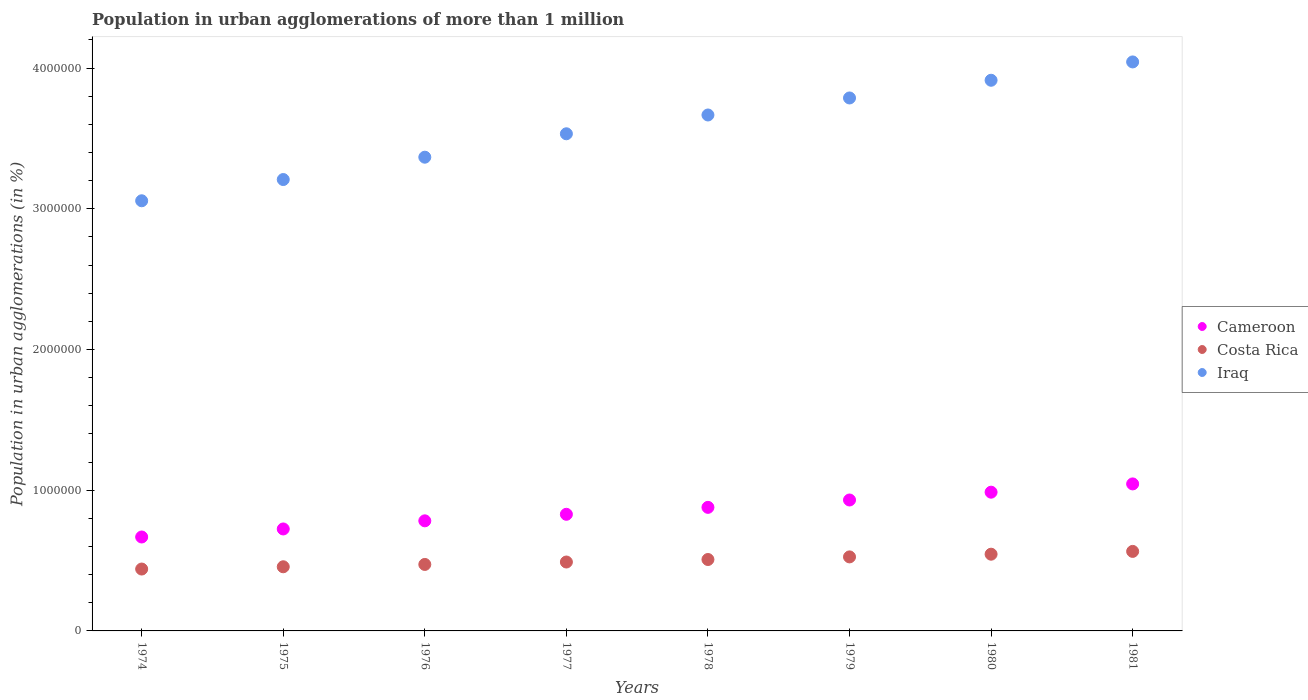How many different coloured dotlines are there?
Make the answer very short. 3. Is the number of dotlines equal to the number of legend labels?
Provide a short and direct response. Yes. What is the population in urban agglomerations in Iraq in 1975?
Give a very brief answer. 3.21e+06. Across all years, what is the maximum population in urban agglomerations in Iraq?
Your answer should be compact. 4.04e+06. Across all years, what is the minimum population in urban agglomerations in Cameroon?
Keep it short and to the point. 6.67e+05. In which year was the population in urban agglomerations in Cameroon maximum?
Give a very brief answer. 1981. In which year was the population in urban agglomerations in Costa Rica minimum?
Ensure brevity in your answer.  1974. What is the total population in urban agglomerations in Costa Rica in the graph?
Your response must be concise. 4.00e+06. What is the difference between the population in urban agglomerations in Iraq in 1979 and that in 1980?
Offer a terse response. -1.26e+05. What is the difference between the population in urban agglomerations in Cameroon in 1981 and the population in urban agglomerations in Costa Rica in 1977?
Your answer should be compact. 5.55e+05. What is the average population in urban agglomerations in Iraq per year?
Your answer should be compact. 3.57e+06. In the year 1978, what is the difference between the population in urban agglomerations in Costa Rica and population in urban agglomerations in Iraq?
Give a very brief answer. -3.16e+06. What is the ratio of the population in urban agglomerations in Iraq in 1974 to that in 1976?
Offer a very short reply. 0.91. Is the population in urban agglomerations in Iraq in 1978 less than that in 1981?
Your answer should be very brief. Yes. Is the difference between the population in urban agglomerations in Costa Rica in 1974 and 1978 greater than the difference between the population in urban agglomerations in Iraq in 1974 and 1978?
Give a very brief answer. Yes. What is the difference between the highest and the second highest population in urban agglomerations in Cameroon?
Make the answer very short. 5.87e+04. What is the difference between the highest and the lowest population in urban agglomerations in Costa Rica?
Keep it short and to the point. 1.25e+05. Is the population in urban agglomerations in Iraq strictly greater than the population in urban agglomerations in Costa Rica over the years?
Your response must be concise. Yes. Is the population in urban agglomerations in Iraq strictly less than the population in urban agglomerations in Costa Rica over the years?
Keep it short and to the point. No. How many dotlines are there?
Your answer should be compact. 3. How many years are there in the graph?
Offer a terse response. 8. What is the difference between two consecutive major ticks on the Y-axis?
Provide a short and direct response. 1.00e+06. Are the values on the major ticks of Y-axis written in scientific E-notation?
Provide a short and direct response. No. Does the graph contain grids?
Your response must be concise. No. How many legend labels are there?
Give a very brief answer. 3. What is the title of the graph?
Your answer should be very brief. Population in urban agglomerations of more than 1 million. What is the label or title of the X-axis?
Your response must be concise. Years. What is the label or title of the Y-axis?
Keep it short and to the point. Population in urban agglomerations (in %). What is the Population in urban agglomerations (in %) of Cameroon in 1974?
Offer a terse response. 6.67e+05. What is the Population in urban agglomerations (in %) of Costa Rica in 1974?
Keep it short and to the point. 4.40e+05. What is the Population in urban agglomerations (in %) of Iraq in 1974?
Your answer should be very brief. 3.06e+06. What is the Population in urban agglomerations (in %) of Cameroon in 1975?
Your response must be concise. 7.25e+05. What is the Population in urban agglomerations (in %) of Costa Rica in 1975?
Your response must be concise. 4.56e+05. What is the Population in urban agglomerations (in %) of Iraq in 1975?
Give a very brief answer. 3.21e+06. What is the Population in urban agglomerations (in %) of Cameroon in 1976?
Give a very brief answer. 7.82e+05. What is the Population in urban agglomerations (in %) of Costa Rica in 1976?
Your answer should be very brief. 4.72e+05. What is the Population in urban agglomerations (in %) in Iraq in 1976?
Provide a short and direct response. 3.37e+06. What is the Population in urban agglomerations (in %) in Cameroon in 1977?
Give a very brief answer. 8.29e+05. What is the Population in urban agglomerations (in %) in Costa Rica in 1977?
Ensure brevity in your answer.  4.90e+05. What is the Population in urban agglomerations (in %) in Iraq in 1977?
Provide a succinct answer. 3.53e+06. What is the Population in urban agglomerations (in %) of Cameroon in 1978?
Provide a short and direct response. 8.78e+05. What is the Population in urban agglomerations (in %) of Costa Rica in 1978?
Give a very brief answer. 5.07e+05. What is the Population in urban agglomerations (in %) in Iraq in 1978?
Your answer should be compact. 3.67e+06. What is the Population in urban agglomerations (in %) of Cameroon in 1979?
Your answer should be very brief. 9.30e+05. What is the Population in urban agglomerations (in %) of Costa Rica in 1979?
Offer a very short reply. 5.26e+05. What is the Population in urban agglomerations (in %) of Iraq in 1979?
Your answer should be compact. 3.79e+06. What is the Population in urban agglomerations (in %) in Cameroon in 1980?
Offer a very short reply. 9.86e+05. What is the Population in urban agglomerations (in %) in Costa Rica in 1980?
Ensure brevity in your answer.  5.45e+05. What is the Population in urban agglomerations (in %) of Iraq in 1980?
Your response must be concise. 3.91e+06. What is the Population in urban agglomerations (in %) of Cameroon in 1981?
Ensure brevity in your answer.  1.04e+06. What is the Population in urban agglomerations (in %) in Costa Rica in 1981?
Provide a short and direct response. 5.65e+05. What is the Population in urban agglomerations (in %) in Iraq in 1981?
Provide a short and direct response. 4.04e+06. Across all years, what is the maximum Population in urban agglomerations (in %) in Cameroon?
Offer a very short reply. 1.04e+06. Across all years, what is the maximum Population in urban agglomerations (in %) in Costa Rica?
Ensure brevity in your answer.  5.65e+05. Across all years, what is the maximum Population in urban agglomerations (in %) in Iraq?
Offer a very short reply. 4.04e+06. Across all years, what is the minimum Population in urban agglomerations (in %) in Cameroon?
Make the answer very short. 6.67e+05. Across all years, what is the minimum Population in urban agglomerations (in %) of Costa Rica?
Your answer should be compact. 4.40e+05. Across all years, what is the minimum Population in urban agglomerations (in %) in Iraq?
Offer a very short reply. 3.06e+06. What is the total Population in urban agglomerations (in %) of Cameroon in the graph?
Your answer should be compact. 6.84e+06. What is the total Population in urban agglomerations (in %) in Costa Rica in the graph?
Offer a very short reply. 4.00e+06. What is the total Population in urban agglomerations (in %) of Iraq in the graph?
Make the answer very short. 2.86e+07. What is the difference between the Population in urban agglomerations (in %) in Cameroon in 1974 and that in 1975?
Provide a succinct answer. -5.71e+04. What is the difference between the Population in urban agglomerations (in %) of Costa Rica in 1974 and that in 1975?
Provide a short and direct response. -1.61e+04. What is the difference between the Population in urban agglomerations (in %) in Iraq in 1974 and that in 1975?
Your response must be concise. -1.51e+05. What is the difference between the Population in urban agglomerations (in %) of Cameroon in 1974 and that in 1976?
Provide a succinct answer. -1.15e+05. What is the difference between the Population in urban agglomerations (in %) of Costa Rica in 1974 and that in 1976?
Make the answer very short. -3.27e+04. What is the difference between the Population in urban agglomerations (in %) of Iraq in 1974 and that in 1976?
Provide a succinct answer. -3.10e+05. What is the difference between the Population in urban agglomerations (in %) in Cameroon in 1974 and that in 1977?
Provide a short and direct response. -1.61e+05. What is the difference between the Population in urban agglomerations (in %) of Costa Rica in 1974 and that in 1977?
Your answer should be very brief. -4.99e+04. What is the difference between the Population in urban agglomerations (in %) of Iraq in 1974 and that in 1977?
Offer a very short reply. -4.76e+05. What is the difference between the Population in urban agglomerations (in %) in Cameroon in 1974 and that in 1978?
Keep it short and to the point. -2.11e+05. What is the difference between the Population in urban agglomerations (in %) in Costa Rica in 1974 and that in 1978?
Offer a terse response. -6.77e+04. What is the difference between the Population in urban agglomerations (in %) in Iraq in 1974 and that in 1978?
Provide a short and direct response. -6.10e+05. What is the difference between the Population in urban agglomerations (in %) of Cameroon in 1974 and that in 1979?
Make the answer very short. -2.63e+05. What is the difference between the Population in urban agglomerations (in %) of Costa Rica in 1974 and that in 1979?
Offer a terse response. -8.63e+04. What is the difference between the Population in urban agglomerations (in %) in Iraq in 1974 and that in 1979?
Provide a short and direct response. -7.31e+05. What is the difference between the Population in urban agglomerations (in %) of Cameroon in 1974 and that in 1980?
Provide a short and direct response. -3.18e+05. What is the difference between the Population in urban agglomerations (in %) in Costa Rica in 1974 and that in 1980?
Ensure brevity in your answer.  -1.05e+05. What is the difference between the Population in urban agglomerations (in %) of Iraq in 1974 and that in 1980?
Your answer should be compact. -8.56e+05. What is the difference between the Population in urban agglomerations (in %) of Cameroon in 1974 and that in 1981?
Provide a succinct answer. -3.77e+05. What is the difference between the Population in urban agglomerations (in %) in Costa Rica in 1974 and that in 1981?
Your response must be concise. -1.25e+05. What is the difference between the Population in urban agglomerations (in %) of Iraq in 1974 and that in 1981?
Your response must be concise. -9.87e+05. What is the difference between the Population in urban agglomerations (in %) of Cameroon in 1975 and that in 1976?
Offer a very short reply. -5.78e+04. What is the difference between the Population in urban agglomerations (in %) in Costa Rica in 1975 and that in 1976?
Offer a terse response. -1.66e+04. What is the difference between the Population in urban agglomerations (in %) of Iraq in 1975 and that in 1976?
Offer a terse response. -1.59e+05. What is the difference between the Population in urban agglomerations (in %) of Cameroon in 1975 and that in 1977?
Provide a succinct answer. -1.04e+05. What is the difference between the Population in urban agglomerations (in %) in Costa Rica in 1975 and that in 1977?
Offer a very short reply. -3.38e+04. What is the difference between the Population in urban agglomerations (in %) in Iraq in 1975 and that in 1977?
Give a very brief answer. -3.25e+05. What is the difference between the Population in urban agglomerations (in %) in Cameroon in 1975 and that in 1978?
Offer a very short reply. -1.54e+05. What is the difference between the Population in urban agglomerations (in %) in Costa Rica in 1975 and that in 1978?
Give a very brief answer. -5.17e+04. What is the difference between the Population in urban agglomerations (in %) of Iraq in 1975 and that in 1978?
Give a very brief answer. -4.59e+05. What is the difference between the Population in urban agglomerations (in %) in Cameroon in 1975 and that in 1979?
Offer a very short reply. -2.06e+05. What is the difference between the Population in urban agglomerations (in %) of Costa Rica in 1975 and that in 1979?
Give a very brief answer. -7.02e+04. What is the difference between the Population in urban agglomerations (in %) of Iraq in 1975 and that in 1979?
Keep it short and to the point. -5.80e+05. What is the difference between the Population in urban agglomerations (in %) in Cameroon in 1975 and that in 1980?
Give a very brief answer. -2.61e+05. What is the difference between the Population in urban agglomerations (in %) in Costa Rica in 1975 and that in 1980?
Offer a terse response. -8.94e+04. What is the difference between the Population in urban agglomerations (in %) in Iraq in 1975 and that in 1980?
Your answer should be very brief. -7.05e+05. What is the difference between the Population in urban agglomerations (in %) in Cameroon in 1975 and that in 1981?
Ensure brevity in your answer.  -3.20e+05. What is the difference between the Population in urban agglomerations (in %) in Costa Rica in 1975 and that in 1981?
Your response must be concise. -1.09e+05. What is the difference between the Population in urban agglomerations (in %) of Iraq in 1975 and that in 1981?
Make the answer very short. -8.36e+05. What is the difference between the Population in urban agglomerations (in %) of Cameroon in 1976 and that in 1977?
Your answer should be very brief. -4.64e+04. What is the difference between the Population in urban agglomerations (in %) of Costa Rica in 1976 and that in 1977?
Make the answer very short. -1.72e+04. What is the difference between the Population in urban agglomerations (in %) in Iraq in 1976 and that in 1977?
Keep it short and to the point. -1.66e+05. What is the difference between the Population in urban agglomerations (in %) in Cameroon in 1976 and that in 1978?
Keep it short and to the point. -9.57e+04. What is the difference between the Population in urban agglomerations (in %) of Costa Rica in 1976 and that in 1978?
Your answer should be compact. -3.51e+04. What is the difference between the Population in urban agglomerations (in %) in Iraq in 1976 and that in 1978?
Offer a terse response. -3.00e+05. What is the difference between the Population in urban agglomerations (in %) of Cameroon in 1976 and that in 1979?
Your answer should be very brief. -1.48e+05. What is the difference between the Population in urban agglomerations (in %) of Costa Rica in 1976 and that in 1979?
Give a very brief answer. -5.36e+04. What is the difference between the Population in urban agglomerations (in %) in Iraq in 1976 and that in 1979?
Ensure brevity in your answer.  -4.21e+05. What is the difference between the Population in urban agglomerations (in %) of Cameroon in 1976 and that in 1980?
Your answer should be very brief. -2.04e+05. What is the difference between the Population in urban agglomerations (in %) of Costa Rica in 1976 and that in 1980?
Your answer should be very brief. -7.28e+04. What is the difference between the Population in urban agglomerations (in %) of Iraq in 1976 and that in 1980?
Your answer should be very brief. -5.47e+05. What is the difference between the Population in urban agglomerations (in %) in Cameroon in 1976 and that in 1981?
Provide a short and direct response. -2.62e+05. What is the difference between the Population in urban agglomerations (in %) of Costa Rica in 1976 and that in 1981?
Give a very brief answer. -9.26e+04. What is the difference between the Population in urban agglomerations (in %) in Iraq in 1976 and that in 1981?
Offer a very short reply. -6.77e+05. What is the difference between the Population in urban agglomerations (in %) in Cameroon in 1977 and that in 1978?
Your answer should be very brief. -4.93e+04. What is the difference between the Population in urban agglomerations (in %) in Costa Rica in 1977 and that in 1978?
Provide a short and direct response. -1.79e+04. What is the difference between the Population in urban agglomerations (in %) of Iraq in 1977 and that in 1978?
Provide a succinct answer. -1.34e+05. What is the difference between the Population in urban agglomerations (in %) of Cameroon in 1977 and that in 1979?
Your answer should be very brief. -1.02e+05. What is the difference between the Population in urban agglomerations (in %) of Costa Rica in 1977 and that in 1979?
Provide a short and direct response. -3.64e+04. What is the difference between the Population in urban agglomerations (in %) of Iraq in 1977 and that in 1979?
Offer a terse response. -2.55e+05. What is the difference between the Population in urban agglomerations (in %) of Cameroon in 1977 and that in 1980?
Offer a terse response. -1.57e+05. What is the difference between the Population in urban agglomerations (in %) of Costa Rica in 1977 and that in 1980?
Offer a terse response. -5.55e+04. What is the difference between the Population in urban agglomerations (in %) of Iraq in 1977 and that in 1980?
Ensure brevity in your answer.  -3.80e+05. What is the difference between the Population in urban agglomerations (in %) of Cameroon in 1977 and that in 1981?
Provide a short and direct response. -2.16e+05. What is the difference between the Population in urban agglomerations (in %) of Costa Rica in 1977 and that in 1981?
Give a very brief answer. -7.54e+04. What is the difference between the Population in urban agglomerations (in %) in Iraq in 1977 and that in 1981?
Provide a short and direct response. -5.11e+05. What is the difference between the Population in urban agglomerations (in %) of Cameroon in 1978 and that in 1979?
Give a very brief answer. -5.23e+04. What is the difference between the Population in urban agglomerations (in %) of Costa Rica in 1978 and that in 1979?
Your answer should be very brief. -1.85e+04. What is the difference between the Population in urban agglomerations (in %) in Iraq in 1978 and that in 1979?
Your response must be concise. -1.21e+05. What is the difference between the Population in urban agglomerations (in %) in Cameroon in 1978 and that in 1980?
Give a very brief answer. -1.08e+05. What is the difference between the Population in urban agglomerations (in %) of Costa Rica in 1978 and that in 1980?
Offer a very short reply. -3.77e+04. What is the difference between the Population in urban agglomerations (in %) of Iraq in 1978 and that in 1980?
Keep it short and to the point. -2.47e+05. What is the difference between the Population in urban agglomerations (in %) of Cameroon in 1978 and that in 1981?
Your response must be concise. -1.67e+05. What is the difference between the Population in urban agglomerations (in %) of Costa Rica in 1978 and that in 1981?
Ensure brevity in your answer.  -5.76e+04. What is the difference between the Population in urban agglomerations (in %) in Iraq in 1978 and that in 1981?
Provide a short and direct response. -3.77e+05. What is the difference between the Population in urban agglomerations (in %) of Cameroon in 1979 and that in 1980?
Offer a terse response. -5.55e+04. What is the difference between the Population in urban agglomerations (in %) in Costa Rica in 1979 and that in 1980?
Offer a terse response. -1.92e+04. What is the difference between the Population in urban agglomerations (in %) of Iraq in 1979 and that in 1980?
Give a very brief answer. -1.26e+05. What is the difference between the Population in urban agglomerations (in %) in Cameroon in 1979 and that in 1981?
Offer a very short reply. -1.14e+05. What is the difference between the Population in urban agglomerations (in %) of Costa Rica in 1979 and that in 1981?
Provide a succinct answer. -3.90e+04. What is the difference between the Population in urban agglomerations (in %) in Iraq in 1979 and that in 1981?
Your answer should be very brief. -2.56e+05. What is the difference between the Population in urban agglomerations (in %) in Cameroon in 1980 and that in 1981?
Make the answer very short. -5.87e+04. What is the difference between the Population in urban agglomerations (in %) of Costa Rica in 1980 and that in 1981?
Provide a succinct answer. -1.99e+04. What is the difference between the Population in urban agglomerations (in %) in Iraq in 1980 and that in 1981?
Ensure brevity in your answer.  -1.30e+05. What is the difference between the Population in urban agglomerations (in %) of Cameroon in 1974 and the Population in urban agglomerations (in %) of Costa Rica in 1975?
Offer a very short reply. 2.12e+05. What is the difference between the Population in urban agglomerations (in %) in Cameroon in 1974 and the Population in urban agglomerations (in %) in Iraq in 1975?
Your answer should be very brief. -2.54e+06. What is the difference between the Population in urban agglomerations (in %) of Costa Rica in 1974 and the Population in urban agglomerations (in %) of Iraq in 1975?
Keep it short and to the point. -2.77e+06. What is the difference between the Population in urban agglomerations (in %) in Cameroon in 1974 and the Population in urban agglomerations (in %) in Costa Rica in 1976?
Ensure brevity in your answer.  1.95e+05. What is the difference between the Population in urban agglomerations (in %) of Cameroon in 1974 and the Population in urban agglomerations (in %) of Iraq in 1976?
Provide a short and direct response. -2.70e+06. What is the difference between the Population in urban agglomerations (in %) in Costa Rica in 1974 and the Population in urban agglomerations (in %) in Iraq in 1976?
Your answer should be very brief. -2.93e+06. What is the difference between the Population in urban agglomerations (in %) in Cameroon in 1974 and the Population in urban agglomerations (in %) in Costa Rica in 1977?
Make the answer very short. 1.78e+05. What is the difference between the Population in urban agglomerations (in %) of Cameroon in 1974 and the Population in urban agglomerations (in %) of Iraq in 1977?
Give a very brief answer. -2.87e+06. What is the difference between the Population in urban agglomerations (in %) of Costa Rica in 1974 and the Population in urban agglomerations (in %) of Iraq in 1977?
Your response must be concise. -3.09e+06. What is the difference between the Population in urban agglomerations (in %) of Cameroon in 1974 and the Population in urban agglomerations (in %) of Costa Rica in 1978?
Make the answer very short. 1.60e+05. What is the difference between the Population in urban agglomerations (in %) of Cameroon in 1974 and the Population in urban agglomerations (in %) of Iraq in 1978?
Provide a succinct answer. -3.00e+06. What is the difference between the Population in urban agglomerations (in %) of Costa Rica in 1974 and the Population in urban agglomerations (in %) of Iraq in 1978?
Provide a succinct answer. -3.23e+06. What is the difference between the Population in urban agglomerations (in %) in Cameroon in 1974 and the Population in urban agglomerations (in %) in Costa Rica in 1979?
Provide a short and direct response. 1.41e+05. What is the difference between the Population in urban agglomerations (in %) of Cameroon in 1974 and the Population in urban agglomerations (in %) of Iraq in 1979?
Your answer should be very brief. -3.12e+06. What is the difference between the Population in urban agglomerations (in %) in Costa Rica in 1974 and the Population in urban agglomerations (in %) in Iraq in 1979?
Keep it short and to the point. -3.35e+06. What is the difference between the Population in urban agglomerations (in %) in Cameroon in 1974 and the Population in urban agglomerations (in %) in Costa Rica in 1980?
Give a very brief answer. 1.22e+05. What is the difference between the Population in urban agglomerations (in %) in Cameroon in 1974 and the Population in urban agglomerations (in %) in Iraq in 1980?
Make the answer very short. -3.25e+06. What is the difference between the Population in urban agglomerations (in %) in Costa Rica in 1974 and the Population in urban agglomerations (in %) in Iraq in 1980?
Offer a terse response. -3.47e+06. What is the difference between the Population in urban agglomerations (in %) of Cameroon in 1974 and the Population in urban agglomerations (in %) of Costa Rica in 1981?
Ensure brevity in your answer.  1.02e+05. What is the difference between the Population in urban agglomerations (in %) in Cameroon in 1974 and the Population in urban agglomerations (in %) in Iraq in 1981?
Your answer should be compact. -3.38e+06. What is the difference between the Population in urban agglomerations (in %) in Costa Rica in 1974 and the Population in urban agglomerations (in %) in Iraq in 1981?
Ensure brevity in your answer.  -3.60e+06. What is the difference between the Population in urban agglomerations (in %) in Cameroon in 1975 and the Population in urban agglomerations (in %) in Costa Rica in 1976?
Give a very brief answer. 2.52e+05. What is the difference between the Population in urban agglomerations (in %) of Cameroon in 1975 and the Population in urban agglomerations (in %) of Iraq in 1976?
Your answer should be compact. -2.64e+06. What is the difference between the Population in urban agglomerations (in %) in Costa Rica in 1975 and the Population in urban agglomerations (in %) in Iraq in 1976?
Offer a very short reply. -2.91e+06. What is the difference between the Population in urban agglomerations (in %) of Cameroon in 1975 and the Population in urban agglomerations (in %) of Costa Rica in 1977?
Offer a very short reply. 2.35e+05. What is the difference between the Population in urban agglomerations (in %) in Cameroon in 1975 and the Population in urban agglomerations (in %) in Iraq in 1977?
Your response must be concise. -2.81e+06. What is the difference between the Population in urban agglomerations (in %) of Costa Rica in 1975 and the Population in urban agglomerations (in %) of Iraq in 1977?
Keep it short and to the point. -3.08e+06. What is the difference between the Population in urban agglomerations (in %) in Cameroon in 1975 and the Population in urban agglomerations (in %) in Costa Rica in 1978?
Your answer should be very brief. 2.17e+05. What is the difference between the Population in urban agglomerations (in %) in Cameroon in 1975 and the Population in urban agglomerations (in %) in Iraq in 1978?
Your response must be concise. -2.94e+06. What is the difference between the Population in urban agglomerations (in %) in Costa Rica in 1975 and the Population in urban agglomerations (in %) in Iraq in 1978?
Ensure brevity in your answer.  -3.21e+06. What is the difference between the Population in urban agglomerations (in %) of Cameroon in 1975 and the Population in urban agglomerations (in %) of Costa Rica in 1979?
Offer a terse response. 1.99e+05. What is the difference between the Population in urban agglomerations (in %) of Cameroon in 1975 and the Population in urban agglomerations (in %) of Iraq in 1979?
Keep it short and to the point. -3.06e+06. What is the difference between the Population in urban agglomerations (in %) in Costa Rica in 1975 and the Population in urban agglomerations (in %) in Iraq in 1979?
Your answer should be very brief. -3.33e+06. What is the difference between the Population in urban agglomerations (in %) of Cameroon in 1975 and the Population in urban agglomerations (in %) of Costa Rica in 1980?
Your response must be concise. 1.79e+05. What is the difference between the Population in urban agglomerations (in %) of Cameroon in 1975 and the Population in urban agglomerations (in %) of Iraq in 1980?
Your response must be concise. -3.19e+06. What is the difference between the Population in urban agglomerations (in %) in Costa Rica in 1975 and the Population in urban agglomerations (in %) in Iraq in 1980?
Make the answer very short. -3.46e+06. What is the difference between the Population in urban agglomerations (in %) in Cameroon in 1975 and the Population in urban agglomerations (in %) in Costa Rica in 1981?
Offer a terse response. 1.59e+05. What is the difference between the Population in urban agglomerations (in %) of Cameroon in 1975 and the Population in urban agglomerations (in %) of Iraq in 1981?
Offer a very short reply. -3.32e+06. What is the difference between the Population in urban agglomerations (in %) in Costa Rica in 1975 and the Population in urban agglomerations (in %) in Iraq in 1981?
Ensure brevity in your answer.  -3.59e+06. What is the difference between the Population in urban agglomerations (in %) in Cameroon in 1976 and the Population in urban agglomerations (in %) in Costa Rica in 1977?
Provide a short and direct response. 2.93e+05. What is the difference between the Population in urban agglomerations (in %) of Cameroon in 1976 and the Population in urban agglomerations (in %) of Iraq in 1977?
Make the answer very short. -2.75e+06. What is the difference between the Population in urban agglomerations (in %) in Costa Rica in 1976 and the Population in urban agglomerations (in %) in Iraq in 1977?
Provide a short and direct response. -3.06e+06. What is the difference between the Population in urban agglomerations (in %) in Cameroon in 1976 and the Population in urban agglomerations (in %) in Costa Rica in 1978?
Keep it short and to the point. 2.75e+05. What is the difference between the Population in urban agglomerations (in %) in Cameroon in 1976 and the Population in urban agglomerations (in %) in Iraq in 1978?
Give a very brief answer. -2.88e+06. What is the difference between the Population in urban agglomerations (in %) of Costa Rica in 1976 and the Population in urban agglomerations (in %) of Iraq in 1978?
Your answer should be compact. -3.19e+06. What is the difference between the Population in urban agglomerations (in %) in Cameroon in 1976 and the Population in urban agglomerations (in %) in Costa Rica in 1979?
Ensure brevity in your answer.  2.56e+05. What is the difference between the Population in urban agglomerations (in %) in Cameroon in 1976 and the Population in urban agglomerations (in %) in Iraq in 1979?
Make the answer very short. -3.00e+06. What is the difference between the Population in urban agglomerations (in %) in Costa Rica in 1976 and the Population in urban agglomerations (in %) in Iraq in 1979?
Offer a terse response. -3.31e+06. What is the difference between the Population in urban agglomerations (in %) in Cameroon in 1976 and the Population in urban agglomerations (in %) in Costa Rica in 1980?
Ensure brevity in your answer.  2.37e+05. What is the difference between the Population in urban agglomerations (in %) in Cameroon in 1976 and the Population in urban agglomerations (in %) in Iraq in 1980?
Keep it short and to the point. -3.13e+06. What is the difference between the Population in urban agglomerations (in %) in Costa Rica in 1976 and the Population in urban agglomerations (in %) in Iraq in 1980?
Your response must be concise. -3.44e+06. What is the difference between the Population in urban agglomerations (in %) of Cameroon in 1976 and the Population in urban agglomerations (in %) of Costa Rica in 1981?
Your answer should be very brief. 2.17e+05. What is the difference between the Population in urban agglomerations (in %) in Cameroon in 1976 and the Population in urban agglomerations (in %) in Iraq in 1981?
Provide a short and direct response. -3.26e+06. What is the difference between the Population in urban agglomerations (in %) of Costa Rica in 1976 and the Population in urban agglomerations (in %) of Iraq in 1981?
Give a very brief answer. -3.57e+06. What is the difference between the Population in urban agglomerations (in %) in Cameroon in 1977 and the Population in urban agglomerations (in %) in Costa Rica in 1978?
Your answer should be very brief. 3.21e+05. What is the difference between the Population in urban agglomerations (in %) in Cameroon in 1977 and the Population in urban agglomerations (in %) in Iraq in 1978?
Offer a terse response. -2.84e+06. What is the difference between the Population in urban agglomerations (in %) in Costa Rica in 1977 and the Population in urban agglomerations (in %) in Iraq in 1978?
Your answer should be compact. -3.18e+06. What is the difference between the Population in urban agglomerations (in %) of Cameroon in 1977 and the Population in urban agglomerations (in %) of Costa Rica in 1979?
Make the answer very short. 3.03e+05. What is the difference between the Population in urban agglomerations (in %) of Cameroon in 1977 and the Population in urban agglomerations (in %) of Iraq in 1979?
Give a very brief answer. -2.96e+06. What is the difference between the Population in urban agglomerations (in %) of Costa Rica in 1977 and the Population in urban agglomerations (in %) of Iraq in 1979?
Your answer should be compact. -3.30e+06. What is the difference between the Population in urban agglomerations (in %) of Cameroon in 1977 and the Population in urban agglomerations (in %) of Costa Rica in 1980?
Offer a very short reply. 2.84e+05. What is the difference between the Population in urban agglomerations (in %) in Cameroon in 1977 and the Population in urban agglomerations (in %) in Iraq in 1980?
Offer a terse response. -3.08e+06. What is the difference between the Population in urban agglomerations (in %) of Costa Rica in 1977 and the Population in urban agglomerations (in %) of Iraq in 1980?
Your answer should be compact. -3.42e+06. What is the difference between the Population in urban agglomerations (in %) in Cameroon in 1977 and the Population in urban agglomerations (in %) in Costa Rica in 1981?
Give a very brief answer. 2.64e+05. What is the difference between the Population in urban agglomerations (in %) of Cameroon in 1977 and the Population in urban agglomerations (in %) of Iraq in 1981?
Make the answer very short. -3.21e+06. What is the difference between the Population in urban agglomerations (in %) of Costa Rica in 1977 and the Population in urban agglomerations (in %) of Iraq in 1981?
Give a very brief answer. -3.55e+06. What is the difference between the Population in urban agglomerations (in %) of Cameroon in 1978 and the Population in urban agglomerations (in %) of Costa Rica in 1979?
Give a very brief answer. 3.52e+05. What is the difference between the Population in urban agglomerations (in %) of Cameroon in 1978 and the Population in urban agglomerations (in %) of Iraq in 1979?
Offer a very short reply. -2.91e+06. What is the difference between the Population in urban agglomerations (in %) of Costa Rica in 1978 and the Population in urban agglomerations (in %) of Iraq in 1979?
Provide a short and direct response. -3.28e+06. What is the difference between the Population in urban agglomerations (in %) of Cameroon in 1978 and the Population in urban agglomerations (in %) of Costa Rica in 1980?
Give a very brief answer. 3.33e+05. What is the difference between the Population in urban agglomerations (in %) in Cameroon in 1978 and the Population in urban agglomerations (in %) in Iraq in 1980?
Keep it short and to the point. -3.03e+06. What is the difference between the Population in urban agglomerations (in %) of Costa Rica in 1978 and the Population in urban agglomerations (in %) of Iraq in 1980?
Your response must be concise. -3.41e+06. What is the difference between the Population in urban agglomerations (in %) of Cameroon in 1978 and the Population in urban agglomerations (in %) of Costa Rica in 1981?
Offer a terse response. 3.13e+05. What is the difference between the Population in urban agglomerations (in %) in Cameroon in 1978 and the Population in urban agglomerations (in %) in Iraq in 1981?
Provide a succinct answer. -3.17e+06. What is the difference between the Population in urban agglomerations (in %) in Costa Rica in 1978 and the Population in urban agglomerations (in %) in Iraq in 1981?
Make the answer very short. -3.54e+06. What is the difference between the Population in urban agglomerations (in %) in Cameroon in 1979 and the Population in urban agglomerations (in %) in Costa Rica in 1980?
Your response must be concise. 3.85e+05. What is the difference between the Population in urban agglomerations (in %) of Cameroon in 1979 and the Population in urban agglomerations (in %) of Iraq in 1980?
Give a very brief answer. -2.98e+06. What is the difference between the Population in urban agglomerations (in %) in Costa Rica in 1979 and the Population in urban agglomerations (in %) in Iraq in 1980?
Provide a short and direct response. -3.39e+06. What is the difference between the Population in urban agglomerations (in %) of Cameroon in 1979 and the Population in urban agglomerations (in %) of Costa Rica in 1981?
Your response must be concise. 3.65e+05. What is the difference between the Population in urban agglomerations (in %) in Cameroon in 1979 and the Population in urban agglomerations (in %) in Iraq in 1981?
Your answer should be compact. -3.11e+06. What is the difference between the Population in urban agglomerations (in %) in Costa Rica in 1979 and the Population in urban agglomerations (in %) in Iraq in 1981?
Your answer should be very brief. -3.52e+06. What is the difference between the Population in urban agglomerations (in %) in Cameroon in 1980 and the Population in urban agglomerations (in %) in Costa Rica in 1981?
Offer a very short reply. 4.21e+05. What is the difference between the Population in urban agglomerations (in %) of Cameroon in 1980 and the Population in urban agglomerations (in %) of Iraq in 1981?
Keep it short and to the point. -3.06e+06. What is the difference between the Population in urban agglomerations (in %) of Costa Rica in 1980 and the Population in urban agglomerations (in %) of Iraq in 1981?
Provide a short and direct response. -3.50e+06. What is the average Population in urban agglomerations (in %) in Cameroon per year?
Ensure brevity in your answer.  8.55e+05. What is the average Population in urban agglomerations (in %) in Costa Rica per year?
Make the answer very short. 5.00e+05. What is the average Population in urban agglomerations (in %) in Iraq per year?
Make the answer very short. 3.57e+06. In the year 1974, what is the difference between the Population in urban agglomerations (in %) in Cameroon and Population in urban agglomerations (in %) in Costa Rica?
Offer a very short reply. 2.28e+05. In the year 1974, what is the difference between the Population in urban agglomerations (in %) of Cameroon and Population in urban agglomerations (in %) of Iraq?
Provide a succinct answer. -2.39e+06. In the year 1974, what is the difference between the Population in urban agglomerations (in %) of Costa Rica and Population in urban agglomerations (in %) of Iraq?
Offer a terse response. -2.62e+06. In the year 1975, what is the difference between the Population in urban agglomerations (in %) of Cameroon and Population in urban agglomerations (in %) of Costa Rica?
Offer a very short reply. 2.69e+05. In the year 1975, what is the difference between the Population in urban agglomerations (in %) in Cameroon and Population in urban agglomerations (in %) in Iraq?
Provide a short and direct response. -2.48e+06. In the year 1975, what is the difference between the Population in urban agglomerations (in %) of Costa Rica and Population in urban agglomerations (in %) of Iraq?
Give a very brief answer. -2.75e+06. In the year 1976, what is the difference between the Population in urban agglomerations (in %) of Cameroon and Population in urban agglomerations (in %) of Costa Rica?
Make the answer very short. 3.10e+05. In the year 1976, what is the difference between the Population in urban agglomerations (in %) in Cameroon and Population in urban agglomerations (in %) in Iraq?
Give a very brief answer. -2.58e+06. In the year 1976, what is the difference between the Population in urban agglomerations (in %) of Costa Rica and Population in urban agglomerations (in %) of Iraq?
Keep it short and to the point. -2.89e+06. In the year 1977, what is the difference between the Population in urban agglomerations (in %) of Cameroon and Population in urban agglomerations (in %) of Costa Rica?
Provide a short and direct response. 3.39e+05. In the year 1977, what is the difference between the Population in urban agglomerations (in %) in Cameroon and Population in urban agglomerations (in %) in Iraq?
Give a very brief answer. -2.70e+06. In the year 1977, what is the difference between the Population in urban agglomerations (in %) in Costa Rica and Population in urban agglomerations (in %) in Iraq?
Keep it short and to the point. -3.04e+06. In the year 1978, what is the difference between the Population in urban agglomerations (in %) of Cameroon and Population in urban agglomerations (in %) of Costa Rica?
Your answer should be very brief. 3.71e+05. In the year 1978, what is the difference between the Population in urban agglomerations (in %) of Cameroon and Population in urban agglomerations (in %) of Iraq?
Your answer should be compact. -2.79e+06. In the year 1978, what is the difference between the Population in urban agglomerations (in %) of Costa Rica and Population in urban agglomerations (in %) of Iraq?
Offer a very short reply. -3.16e+06. In the year 1979, what is the difference between the Population in urban agglomerations (in %) in Cameroon and Population in urban agglomerations (in %) in Costa Rica?
Keep it short and to the point. 4.04e+05. In the year 1979, what is the difference between the Population in urban agglomerations (in %) in Cameroon and Population in urban agglomerations (in %) in Iraq?
Provide a short and direct response. -2.86e+06. In the year 1979, what is the difference between the Population in urban agglomerations (in %) of Costa Rica and Population in urban agglomerations (in %) of Iraq?
Provide a succinct answer. -3.26e+06. In the year 1980, what is the difference between the Population in urban agglomerations (in %) in Cameroon and Population in urban agglomerations (in %) in Costa Rica?
Ensure brevity in your answer.  4.41e+05. In the year 1980, what is the difference between the Population in urban agglomerations (in %) in Cameroon and Population in urban agglomerations (in %) in Iraq?
Ensure brevity in your answer.  -2.93e+06. In the year 1980, what is the difference between the Population in urban agglomerations (in %) in Costa Rica and Population in urban agglomerations (in %) in Iraq?
Offer a terse response. -3.37e+06. In the year 1981, what is the difference between the Population in urban agglomerations (in %) of Cameroon and Population in urban agglomerations (in %) of Costa Rica?
Offer a terse response. 4.80e+05. In the year 1981, what is the difference between the Population in urban agglomerations (in %) in Cameroon and Population in urban agglomerations (in %) in Iraq?
Ensure brevity in your answer.  -3.00e+06. In the year 1981, what is the difference between the Population in urban agglomerations (in %) of Costa Rica and Population in urban agglomerations (in %) of Iraq?
Ensure brevity in your answer.  -3.48e+06. What is the ratio of the Population in urban agglomerations (in %) in Cameroon in 1974 to that in 1975?
Keep it short and to the point. 0.92. What is the ratio of the Population in urban agglomerations (in %) in Costa Rica in 1974 to that in 1975?
Your response must be concise. 0.96. What is the ratio of the Population in urban agglomerations (in %) in Iraq in 1974 to that in 1975?
Your answer should be very brief. 0.95. What is the ratio of the Population in urban agglomerations (in %) in Cameroon in 1974 to that in 1976?
Offer a terse response. 0.85. What is the ratio of the Population in urban agglomerations (in %) in Costa Rica in 1974 to that in 1976?
Your response must be concise. 0.93. What is the ratio of the Population in urban agglomerations (in %) of Iraq in 1974 to that in 1976?
Your answer should be compact. 0.91. What is the ratio of the Population in urban agglomerations (in %) in Cameroon in 1974 to that in 1977?
Your answer should be compact. 0.81. What is the ratio of the Population in urban agglomerations (in %) in Costa Rica in 1974 to that in 1977?
Provide a succinct answer. 0.9. What is the ratio of the Population in urban agglomerations (in %) in Iraq in 1974 to that in 1977?
Keep it short and to the point. 0.87. What is the ratio of the Population in urban agglomerations (in %) of Cameroon in 1974 to that in 1978?
Keep it short and to the point. 0.76. What is the ratio of the Population in urban agglomerations (in %) of Costa Rica in 1974 to that in 1978?
Make the answer very short. 0.87. What is the ratio of the Population in urban agglomerations (in %) in Iraq in 1974 to that in 1978?
Offer a very short reply. 0.83. What is the ratio of the Population in urban agglomerations (in %) of Cameroon in 1974 to that in 1979?
Your answer should be very brief. 0.72. What is the ratio of the Population in urban agglomerations (in %) in Costa Rica in 1974 to that in 1979?
Offer a very short reply. 0.84. What is the ratio of the Population in urban agglomerations (in %) of Iraq in 1974 to that in 1979?
Keep it short and to the point. 0.81. What is the ratio of the Population in urban agglomerations (in %) in Cameroon in 1974 to that in 1980?
Provide a succinct answer. 0.68. What is the ratio of the Population in urban agglomerations (in %) in Costa Rica in 1974 to that in 1980?
Your response must be concise. 0.81. What is the ratio of the Population in urban agglomerations (in %) in Iraq in 1974 to that in 1980?
Your response must be concise. 0.78. What is the ratio of the Population in urban agglomerations (in %) of Cameroon in 1974 to that in 1981?
Your answer should be compact. 0.64. What is the ratio of the Population in urban agglomerations (in %) in Costa Rica in 1974 to that in 1981?
Your response must be concise. 0.78. What is the ratio of the Population in urban agglomerations (in %) of Iraq in 1974 to that in 1981?
Offer a very short reply. 0.76. What is the ratio of the Population in urban agglomerations (in %) of Cameroon in 1975 to that in 1976?
Your answer should be compact. 0.93. What is the ratio of the Population in urban agglomerations (in %) of Costa Rica in 1975 to that in 1976?
Keep it short and to the point. 0.96. What is the ratio of the Population in urban agglomerations (in %) of Iraq in 1975 to that in 1976?
Your answer should be very brief. 0.95. What is the ratio of the Population in urban agglomerations (in %) in Cameroon in 1975 to that in 1977?
Ensure brevity in your answer.  0.87. What is the ratio of the Population in urban agglomerations (in %) of Costa Rica in 1975 to that in 1977?
Offer a terse response. 0.93. What is the ratio of the Population in urban agglomerations (in %) of Iraq in 1975 to that in 1977?
Your answer should be compact. 0.91. What is the ratio of the Population in urban agglomerations (in %) in Cameroon in 1975 to that in 1978?
Offer a terse response. 0.83. What is the ratio of the Population in urban agglomerations (in %) in Costa Rica in 1975 to that in 1978?
Give a very brief answer. 0.9. What is the ratio of the Population in urban agglomerations (in %) of Iraq in 1975 to that in 1978?
Keep it short and to the point. 0.87. What is the ratio of the Population in urban agglomerations (in %) of Cameroon in 1975 to that in 1979?
Ensure brevity in your answer.  0.78. What is the ratio of the Population in urban agglomerations (in %) of Costa Rica in 1975 to that in 1979?
Ensure brevity in your answer.  0.87. What is the ratio of the Population in urban agglomerations (in %) in Iraq in 1975 to that in 1979?
Make the answer very short. 0.85. What is the ratio of the Population in urban agglomerations (in %) in Cameroon in 1975 to that in 1980?
Your answer should be compact. 0.73. What is the ratio of the Population in urban agglomerations (in %) of Costa Rica in 1975 to that in 1980?
Offer a very short reply. 0.84. What is the ratio of the Population in urban agglomerations (in %) in Iraq in 1975 to that in 1980?
Provide a short and direct response. 0.82. What is the ratio of the Population in urban agglomerations (in %) in Cameroon in 1975 to that in 1981?
Offer a terse response. 0.69. What is the ratio of the Population in urban agglomerations (in %) in Costa Rica in 1975 to that in 1981?
Provide a short and direct response. 0.81. What is the ratio of the Population in urban agglomerations (in %) of Iraq in 1975 to that in 1981?
Keep it short and to the point. 0.79. What is the ratio of the Population in urban agglomerations (in %) of Cameroon in 1976 to that in 1977?
Ensure brevity in your answer.  0.94. What is the ratio of the Population in urban agglomerations (in %) in Costa Rica in 1976 to that in 1977?
Your response must be concise. 0.96. What is the ratio of the Population in urban agglomerations (in %) in Iraq in 1976 to that in 1977?
Your answer should be compact. 0.95. What is the ratio of the Population in urban agglomerations (in %) in Cameroon in 1976 to that in 1978?
Make the answer very short. 0.89. What is the ratio of the Population in urban agglomerations (in %) of Costa Rica in 1976 to that in 1978?
Offer a terse response. 0.93. What is the ratio of the Population in urban agglomerations (in %) in Iraq in 1976 to that in 1978?
Provide a short and direct response. 0.92. What is the ratio of the Population in urban agglomerations (in %) of Cameroon in 1976 to that in 1979?
Offer a terse response. 0.84. What is the ratio of the Population in urban agglomerations (in %) in Costa Rica in 1976 to that in 1979?
Provide a succinct answer. 0.9. What is the ratio of the Population in urban agglomerations (in %) in Iraq in 1976 to that in 1979?
Make the answer very short. 0.89. What is the ratio of the Population in urban agglomerations (in %) in Cameroon in 1976 to that in 1980?
Make the answer very short. 0.79. What is the ratio of the Population in urban agglomerations (in %) of Costa Rica in 1976 to that in 1980?
Keep it short and to the point. 0.87. What is the ratio of the Population in urban agglomerations (in %) of Iraq in 1976 to that in 1980?
Provide a short and direct response. 0.86. What is the ratio of the Population in urban agglomerations (in %) of Cameroon in 1976 to that in 1981?
Provide a short and direct response. 0.75. What is the ratio of the Population in urban agglomerations (in %) of Costa Rica in 1976 to that in 1981?
Your answer should be compact. 0.84. What is the ratio of the Population in urban agglomerations (in %) of Iraq in 1976 to that in 1981?
Provide a short and direct response. 0.83. What is the ratio of the Population in urban agglomerations (in %) in Cameroon in 1977 to that in 1978?
Make the answer very short. 0.94. What is the ratio of the Population in urban agglomerations (in %) of Costa Rica in 1977 to that in 1978?
Offer a very short reply. 0.96. What is the ratio of the Population in urban agglomerations (in %) of Iraq in 1977 to that in 1978?
Your answer should be very brief. 0.96. What is the ratio of the Population in urban agglomerations (in %) of Cameroon in 1977 to that in 1979?
Provide a short and direct response. 0.89. What is the ratio of the Population in urban agglomerations (in %) in Costa Rica in 1977 to that in 1979?
Your response must be concise. 0.93. What is the ratio of the Population in urban agglomerations (in %) of Iraq in 1977 to that in 1979?
Your answer should be compact. 0.93. What is the ratio of the Population in urban agglomerations (in %) in Cameroon in 1977 to that in 1980?
Your answer should be very brief. 0.84. What is the ratio of the Population in urban agglomerations (in %) in Costa Rica in 1977 to that in 1980?
Keep it short and to the point. 0.9. What is the ratio of the Population in urban agglomerations (in %) in Iraq in 1977 to that in 1980?
Your answer should be compact. 0.9. What is the ratio of the Population in urban agglomerations (in %) of Cameroon in 1977 to that in 1981?
Keep it short and to the point. 0.79. What is the ratio of the Population in urban agglomerations (in %) in Costa Rica in 1977 to that in 1981?
Provide a short and direct response. 0.87. What is the ratio of the Population in urban agglomerations (in %) in Iraq in 1977 to that in 1981?
Give a very brief answer. 0.87. What is the ratio of the Population in urban agglomerations (in %) in Cameroon in 1978 to that in 1979?
Provide a short and direct response. 0.94. What is the ratio of the Population in urban agglomerations (in %) in Costa Rica in 1978 to that in 1979?
Your answer should be compact. 0.96. What is the ratio of the Population in urban agglomerations (in %) in Iraq in 1978 to that in 1979?
Offer a terse response. 0.97. What is the ratio of the Population in urban agglomerations (in %) of Cameroon in 1978 to that in 1980?
Make the answer very short. 0.89. What is the ratio of the Population in urban agglomerations (in %) of Costa Rica in 1978 to that in 1980?
Your answer should be compact. 0.93. What is the ratio of the Population in urban agglomerations (in %) of Iraq in 1978 to that in 1980?
Offer a terse response. 0.94. What is the ratio of the Population in urban agglomerations (in %) in Cameroon in 1978 to that in 1981?
Offer a terse response. 0.84. What is the ratio of the Population in urban agglomerations (in %) in Costa Rica in 1978 to that in 1981?
Provide a short and direct response. 0.9. What is the ratio of the Population in urban agglomerations (in %) in Iraq in 1978 to that in 1981?
Provide a succinct answer. 0.91. What is the ratio of the Population in urban agglomerations (in %) in Cameroon in 1979 to that in 1980?
Provide a succinct answer. 0.94. What is the ratio of the Population in urban agglomerations (in %) in Costa Rica in 1979 to that in 1980?
Your response must be concise. 0.96. What is the ratio of the Population in urban agglomerations (in %) of Iraq in 1979 to that in 1980?
Make the answer very short. 0.97. What is the ratio of the Population in urban agglomerations (in %) of Cameroon in 1979 to that in 1981?
Keep it short and to the point. 0.89. What is the ratio of the Population in urban agglomerations (in %) of Costa Rica in 1979 to that in 1981?
Provide a succinct answer. 0.93. What is the ratio of the Population in urban agglomerations (in %) of Iraq in 1979 to that in 1981?
Offer a very short reply. 0.94. What is the ratio of the Population in urban agglomerations (in %) of Cameroon in 1980 to that in 1981?
Ensure brevity in your answer.  0.94. What is the ratio of the Population in urban agglomerations (in %) of Costa Rica in 1980 to that in 1981?
Make the answer very short. 0.96. What is the ratio of the Population in urban agglomerations (in %) of Iraq in 1980 to that in 1981?
Give a very brief answer. 0.97. What is the difference between the highest and the second highest Population in urban agglomerations (in %) of Cameroon?
Your answer should be very brief. 5.87e+04. What is the difference between the highest and the second highest Population in urban agglomerations (in %) in Costa Rica?
Provide a short and direct response. 1.99e+04. What is the difference between the highest and the second highest Population in urban agglomerations (in %) of Iraq?
Your response must be concise. 1.30e+05. What is the difference between the highest and the lowest Population in urban agglomerations (in %) of Cameroon?
Keep it short and to the point. 3.77e+05. What is the difference between the highest and the lowest Population in urban agglomerations (in %) in Costa Rica?
Your response must be concise. 1.25e+05. What is the difference between the highest and the lowest Population in urban agglomerations (in %) in Iraq?
Provide a succinct answer. 9.87e+05. 